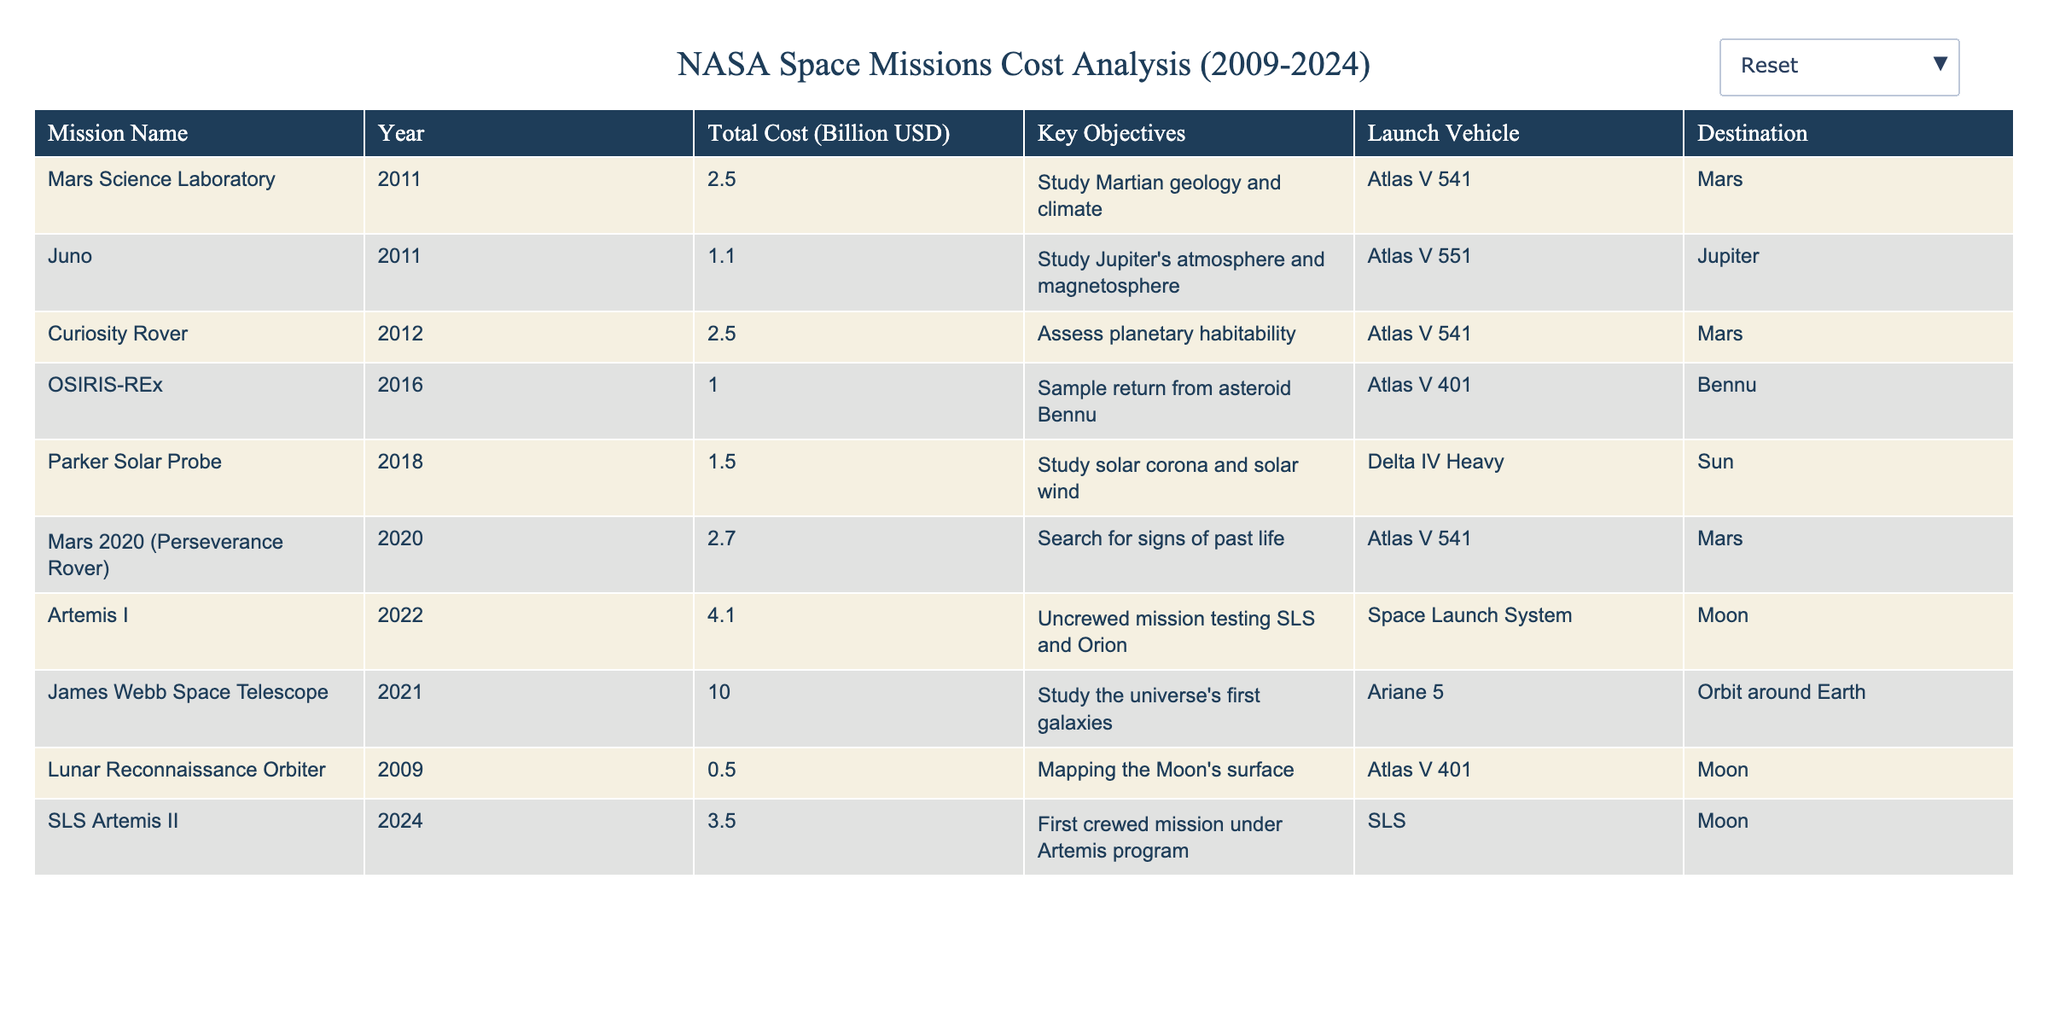What is the total cost of the Mars Science Laboratory mission? The cost of the Mars Science Laboratory mission is specifically listed in the table under the "Total Cost" column for the year 2011, which shows a value of 2.5 billion USD.
Answer: 2.5 billion USD Which mission has the highest total cost? The table indicates the total costs for various missions. Comparing these values, the James Webb Space Telescope in 2021 has the highest total cost at 10.0 billion USD.
Answer: James Webb Space Telescope How many missions had a total cost of over 2 billion USD? By inspecting the "Total Cost" column, we find that there are four missions (Mars Science Laboratory, Curiosity Rover, Mars 2020, and James Webb Space Telescope) with costs exceeding 2 billion USD.
Answer: 4 What was the average cost of all missions launched between 2011 and 2020? First, we sum the total costs of missions launched between 2011 and 2020: 2.5 + 1.1 + 2.5 + 1.0 + 1.5 + 2.7 = 10.3 billion USD. There are 6 missions, so the average cost is 10.3 / 6 = 1.717 billion USD.
Answer: 1.717 billion USD Is the Parker Solar Probe mission focused on lunar exploration? The Parker Solar Probe mission's key objective is to study the solar corona and solar wind, as stated in the key objectives column, while lunar exploration relates to the Moon, which is not mentioned for this mission. Therefore, it is false.
Answer: No What is the cost difference between the Artemis I and Artemis II missions? The total cost for Artemis I is 4.1 billion USD, and for Artemis II, it is 3.5 billion USD. To find the cost difference, we subtract 3.5 from 4.1, resulting in a difference of 0.6 billion USD.
Answer: 0.6 billion USD List the launch vehicles used for Mars missions only. The table indicates that several Mars missions used the Atlas V 541 launch vehicle. Specifically, the Mars Science Laboratory, Curiosity Rover, and Mars 2020 missions all utilized either Atlas V or variants (Atlas V 541 in the case of the first and last, and Atlas V 541 for Curiosity).
Answer: Atlas V 541 Which year saw the launch of the most expensive mission? By reviewing the "Year" and "Total Cost" columns, the most costly mission, the James Webb Space Telescope, launched in 2021, making it the year with the most expensive mission.
Answer: 2021 